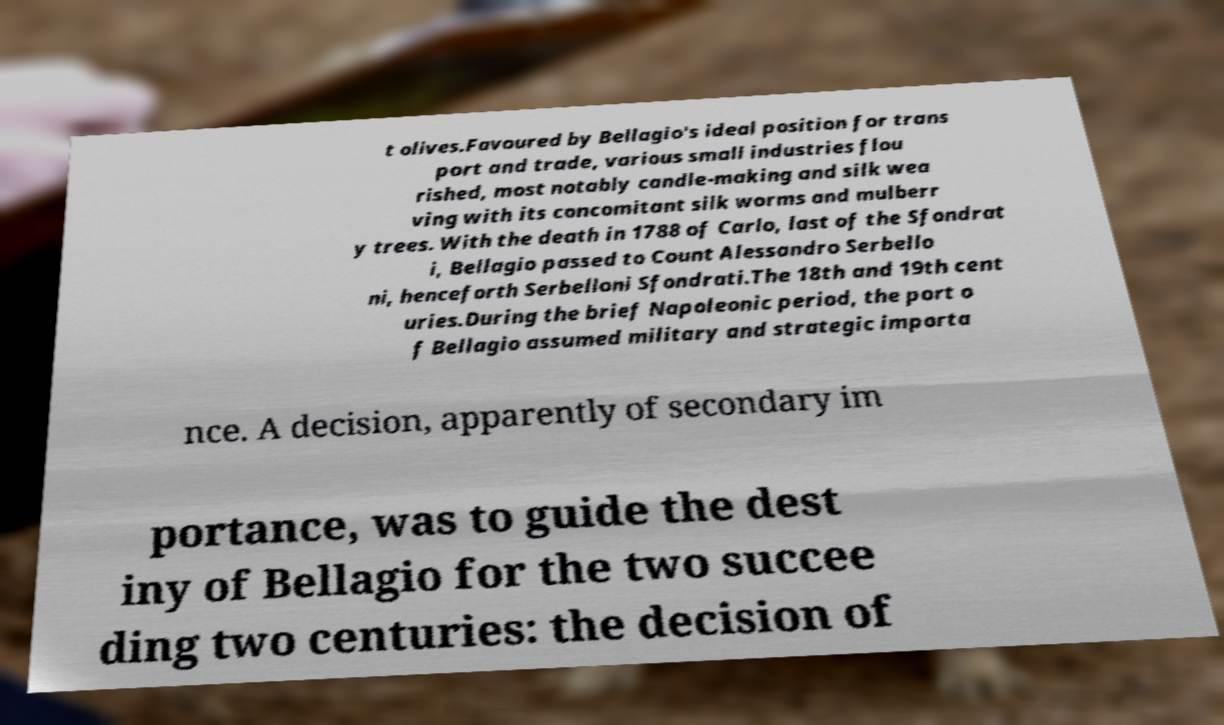I need the written content from this picture converted into text. Can you do that? t olives.Favoured by Bellagio's ideal position for trans port and trade, various small industries flou rished, most notably candle-making and silk wea ving with its concomitant silk worms and mulberr y trees. With the death in 1788 of Carlo, last of the Sfondrat i, Bellagio passed to Count Alessandro Serbello ni, henceforth Serbelloni Sfondrati.The 18th and 19th cent uries.During the brief Napoleonic period, the port o f Bellagio assumed military and strategic importa nce. A decision, apparently of secondary im portance, was to guide the dest iny of Bellagio for the two succee ding two centuries: the decision of 